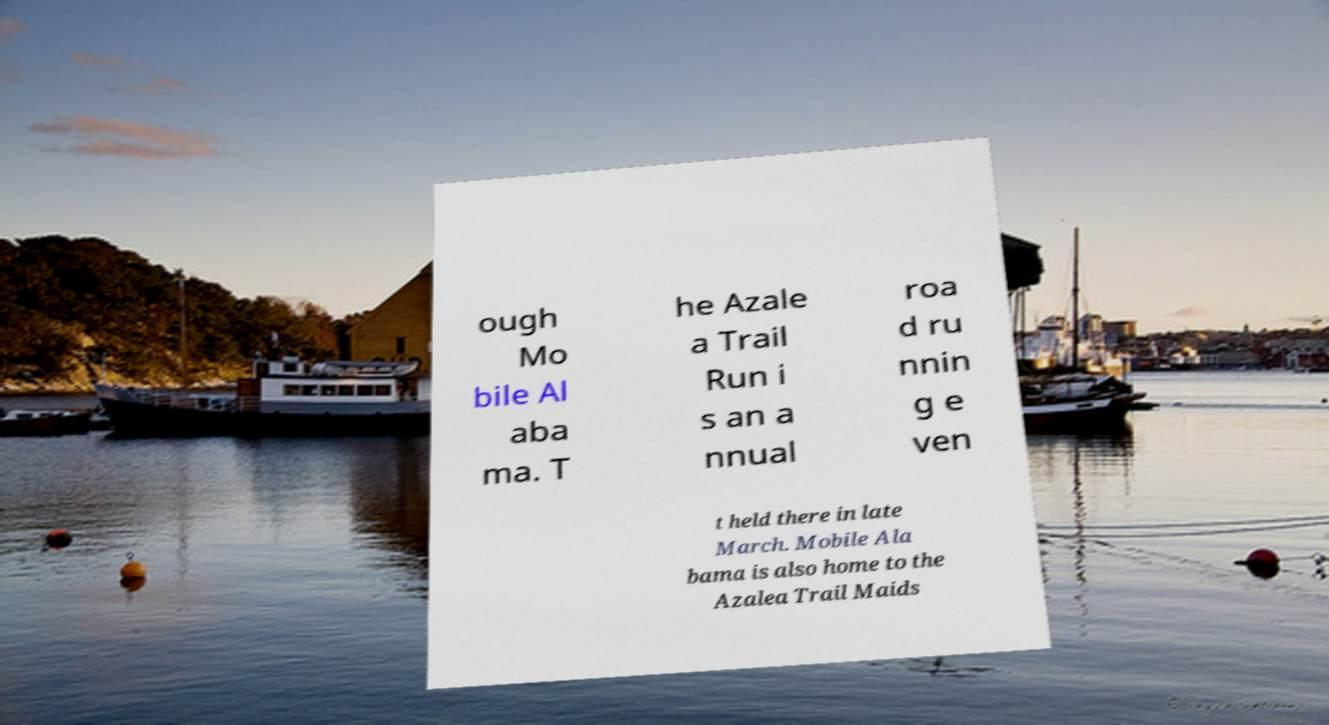For documentation purposes, I need the text within this image transcribed. Could you provide that? ough Mo bile Al aba ma. T he Azale a Trail Run i s an a nnual roa d ru nnin g e ven t held there in late March. Mobile Ala bama is also home to the Azalea Trail Maids 